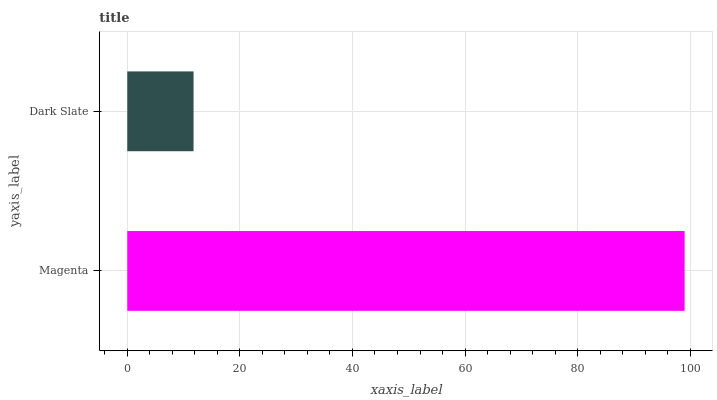Is Dark Slate the minimum?
Answer yes or no. Yes. Is Magenta the maximum?
Answer yes or no. Yes. Is Dark Slate the maximum?
Answer yes or no. No. Is Magenta greater than Dark Slate?
Answer yes or no. Yes. Is Dark Slate less than Magenta?
Answer yes or no. Yes. Is Dark Slate greater than Magenta?
Answer yes or no. No. Is Magenta less than Dark Slate?
Answer yes or no. No. Is Magenta the high median?
Answer yes or no. Yes. Is Dark Slate the low median?
Answer yes or no. Yes. Is Dark Slate the high median?
Answer yes or no. No. Is Magenta the low median?
Answer yes or no. No. 